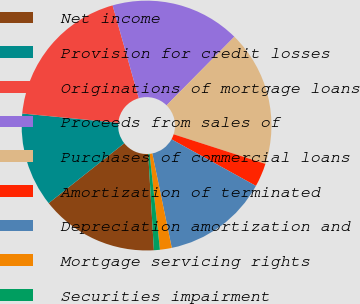Convert chart. <chart><loc_0><loc_0><loc_500><loc_500><pie_chart><fcel>Net income<fcel>Provision for credit losses<fcel>Originations of mortgage loans<fcel>Proceeds from sales of<fcel>Purchases of commercial loans<fcel>Amortization of terminated<fcel>Depreciation amortization and<fcel>Mortgage servicing rights<fcel>Securities impairment<nl><fcel>15.27%<fcel>12.21%<fcel>19.08%<fcel>16.79%<fcel>17.56%<fcel>3.06%<fcel>13.74%<fcel>1.53%<fcel>0.77%<nl></chart> 